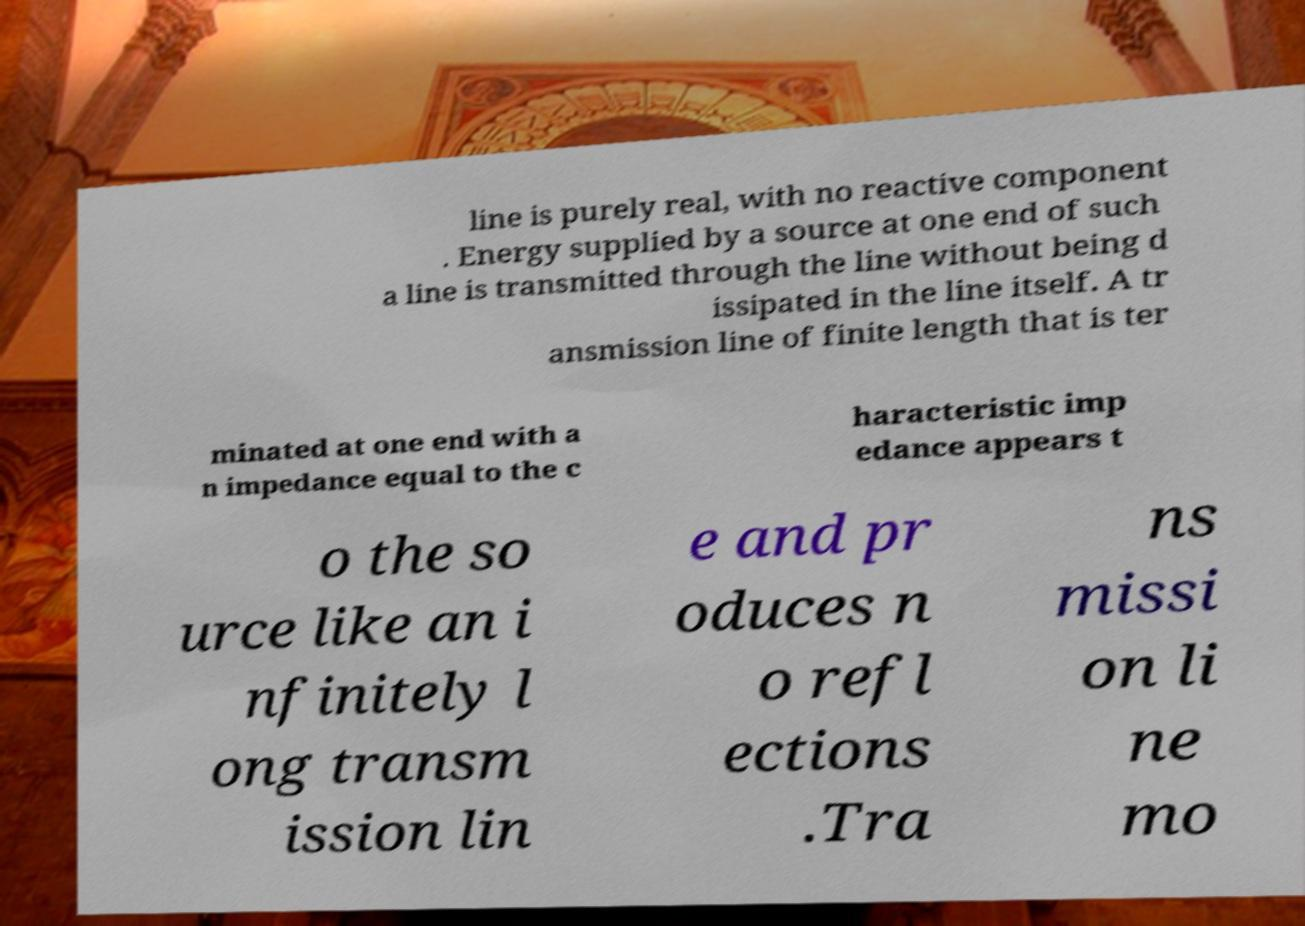For documentation purposes, I need the text within this image transcribed. Could you provide that? line is purely real, with no reactive component . Energy supplied by a source at one end of such a line is transmitted through the line without being d issipated in the line itself. A tr ansmission line of finite length that is ter minated at one end with a n impedance equal to the c haracteristic imp edance appears t o the so urce like an i nfinitely l ong transm ission lin e and pr oduces n o refl ections .Tra ns missi on li ne mo 